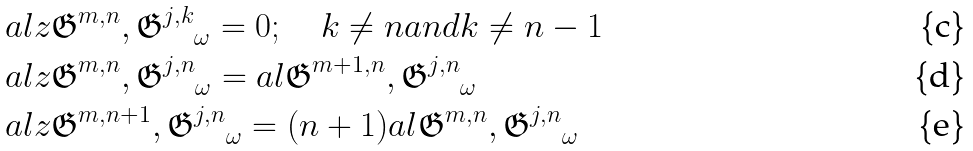<formula> <loc_0><loc_0><loc_500><loc_500>& a l { z \mathfrak { G } ^ { m , n } , \mathfrak { G } ^ { j , k } } _ { \omega } = 0 ; \quad k \ne n a n d k \ne n - 1 \\ & a l { z \mathfrak { G } ^ { m , n } , \mathfrak { G } ^ { j , n } } _ { \omega } = a l { \mathfrak { G } ^ { m + 1 , n } , \mathfrak { G } ^ { j , n } } _ { \omega } \\ & a l { z \mathfrak { G } ^ { m , n + 1 } , \mathfrak { G } ^ { j , n } } _ { \omega } = ( n + 1 ) a l { \mathfrak { G } ^ { m , n } , \mathfrak { G } ^ { j , n } } _ { \omega }</formula> 